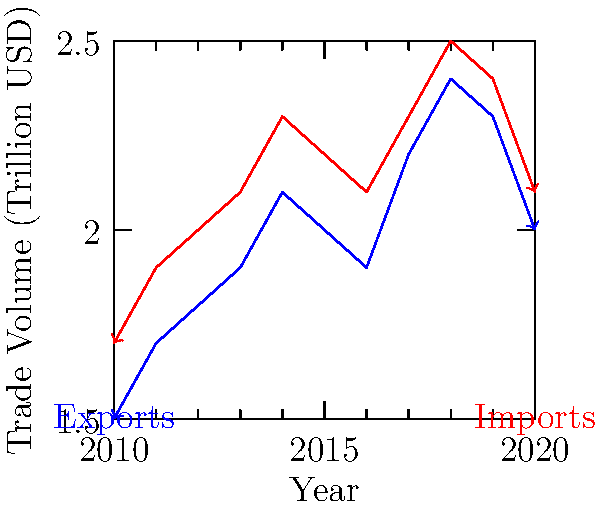Analyzing the line graph depicting global trade trends from 2010 to 2020, what significant pattern emerges in the relationship between imports and exports, and how might this relate to global economic events during this period? To answer this question, let's analyze the graph step-by-step:

1. Overall trend: Both imports and exports show an upward trend from 2010 to 2018, followed by a decline from 2018 to 2020.

2. Relationship between imports and exports:
   - Imports (red line) consistently remain higher than exports (blue line) throughout the entire period.
   - The gap between imports and exports remains relatively constant, indicating a persistent trade deficit.

3. Key observations:
   - Peak: Both imports and exports reach their highest point in 2018 (approximately 2.5 trillion USD for imports and 2.4 trillion USD for exports).
   - Sharp decline: There's a notable decrease in both imports and exports from 2018 to 2020.

4. Relating to global economic events:
   - The upward trend until 2018 might reflect global economic growth and increasing globalization.
   - The sharp decline from 2018 to 2020 could be attributed to:
     a) Trade tensions and tariff wars, particularly between major economies like the US and China.
     b) The onset of the COVID-19 pandemic in 2020, which severely disrupted global trade.

5. Significance for international politics and diplomacy:
   - The persistent trade deficit (imports exceeding exports) could be a point of contention in international trade negotiations.
   - The sharp decline in 2019-2020 might lead to increased protectionist policies or, conversely, renewed efforts for international cooperation to revitalize global trade.
Answer: Persistent trade deficit with parallel growth until 2018, followed by sharp decline likely due to trade tensions and COVID-19 pandemic. 